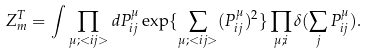<formula> <loc_0><loc_0><loc_500><loc_500>Z _ { m } ^ { T } = \int \prod _ { \mu ; < { i j } > } d P ^ { \mu } _ { i j } \exp \{ \sum _ { \mu ; < { i j } > } ( P ^ { \mu } _ { i j } ) ^ { 2 } \} \prod _ { \mu ; i } \delta ( \sum _ { j } P ^ { \mu } _ { i j } ) .</formula> 